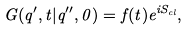Convert formula to latex. <formula><loc_0><loc_0><loc_500><loc_500>G ( q ^ { \prime } , t | q ^ { \prime \prime } , 0 ) = f ( t ) e ^ { i S _ { c l } } ,</formula> 